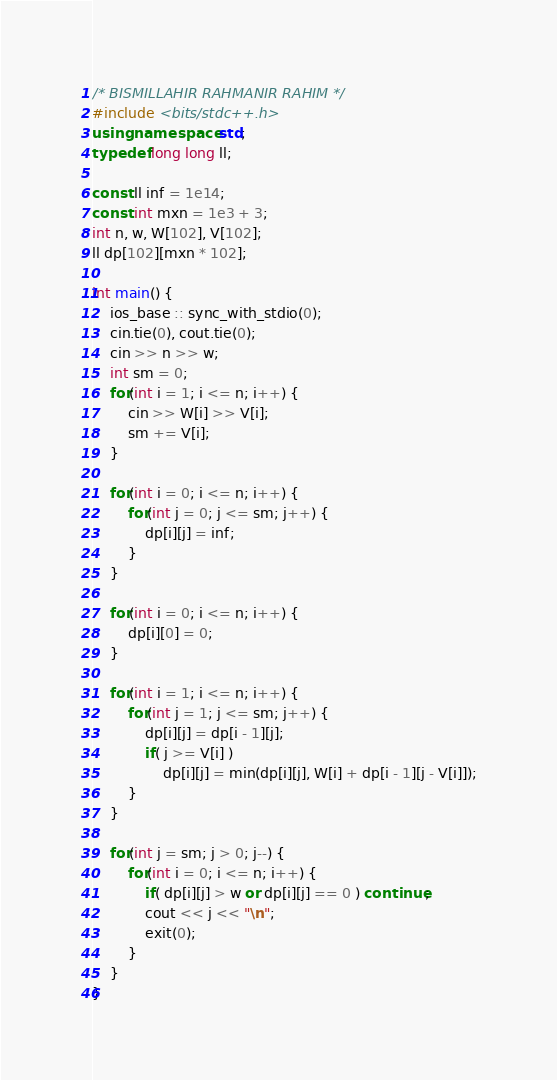<code> <loc_0><loc_0><loc_500><loc_500><_C++_>/* BISMILLAHIR RAHMANIR RAHIM */
#include <bits/stdc++.h>
using namespace std;
typedef long long ll;

const ll inf = 1e14;
const int mxn = 1e3 + 3;
int n, w, W[102], V[102];
ll dp[102][mxn * 102];

int main() {
	ios_base :: sync_with_stdio(0);
	cin.tie(0), cout.tie(0);
	cin >> n >> w;
	int sm = 0;
	for(int i = 1; i <= n; i++) {
		cin >> W[i] >> V[i];
		sm += V[i];
	}
	
	for(int i = 0; i <= n; i++) {
		for(int j = 0; j <= sm; j++) {
			dp[i][j] = inf;
		}
	}

	for(int i = 0; i <= n; i++) {
		dp[i][0] = 0;
	}

	for(int i = 1; i <= n; i++) {
		for(int j = 1; j <= sm; j++) {
			dp[i][j] = dp[i - 1][j];
			if( j >= V[i] ) 
				dp[i][j] = min(dp[i][j], W[i] + dp[i - 1][j - V[i]]);
		}
	}

	for(int j = sm; j > 0; j--) {
		for(int i = 0; i <= n; i++) {
			if( dp[i][j] > w or dp[i][j] == 0 ) continue;
			cout << j << "\n";
			exit(0);
		}
	}
} </code> 